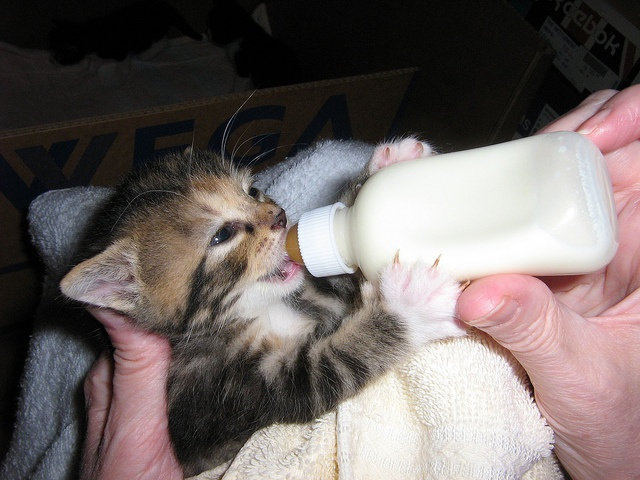Describe the objects in this image and their specific colors. I can see cat in black, gray, darkgray, and lightgray tones, people in black, lightpink, gray, and darkgray tones, and bottle in black, white, darkgray, pink, and lightgray tones in this image. 